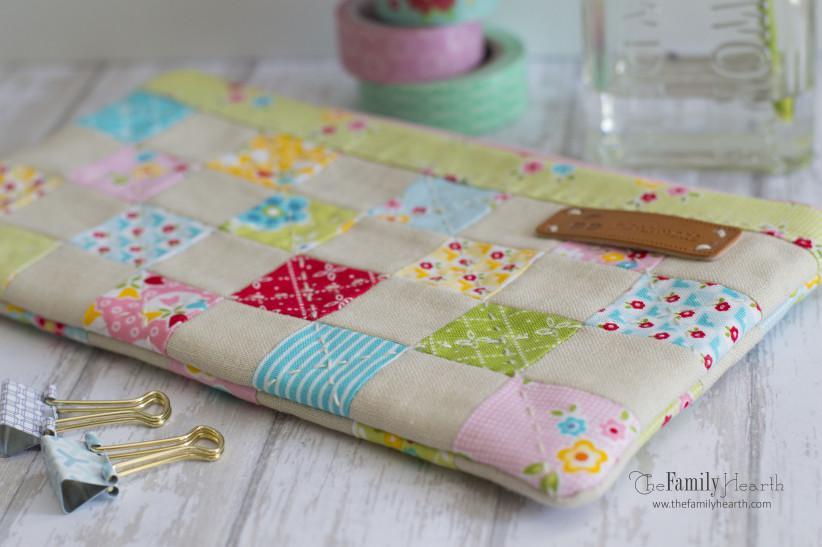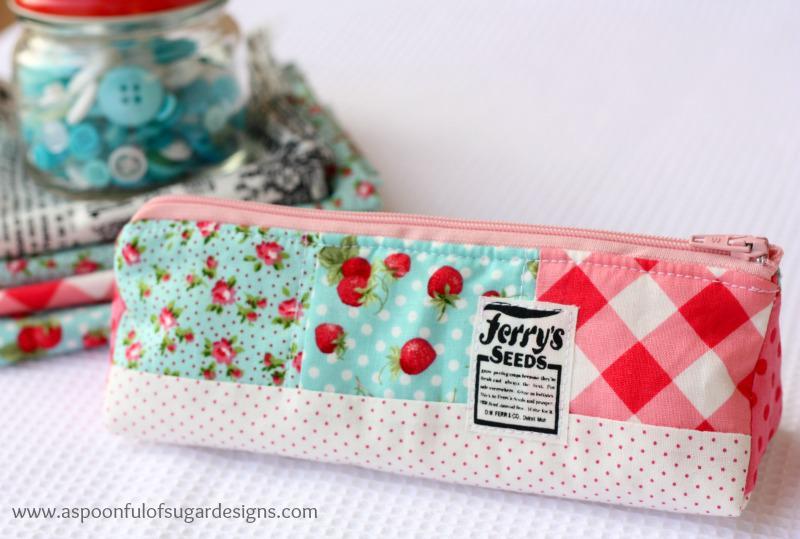The first image is the image on the left, the second image is the image on the right. For the images displayed, is the sentence "Color pencils are poking out of a pencil case in the image on the left." factually correct? Answer yes or no. No. The first image is the image on the left, the second image is the image on the right. For the images displayed, is the sentence "An image shows a set of colored pencils sticking out of a soft pencil case." factually correct? Answer yes or no. No. 